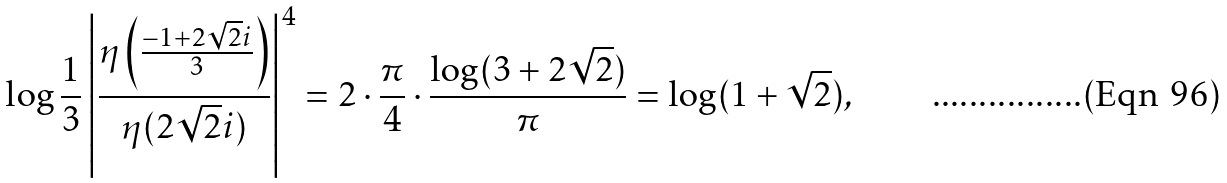Convert formula to latex. <formula><loc_0><loc_0><loc_500><loc_500>\log \frac { 1 } { 3 } \left | \frac { \eta \left ( \frac { - 1 + 2 \sqrt { 2 } i } { 3 } \right ) } { \eta ( 2 \sqrt { 2 } i ) } \right | ^ { 4 } = 2 \cdot \frac { \pi } { 4 } \cdot \frac { \log ( 3 + 2 \sqrt { 2 } ) } { \pi } = \log ( 1 + \sqrt { 2 } ) ,</formula> 